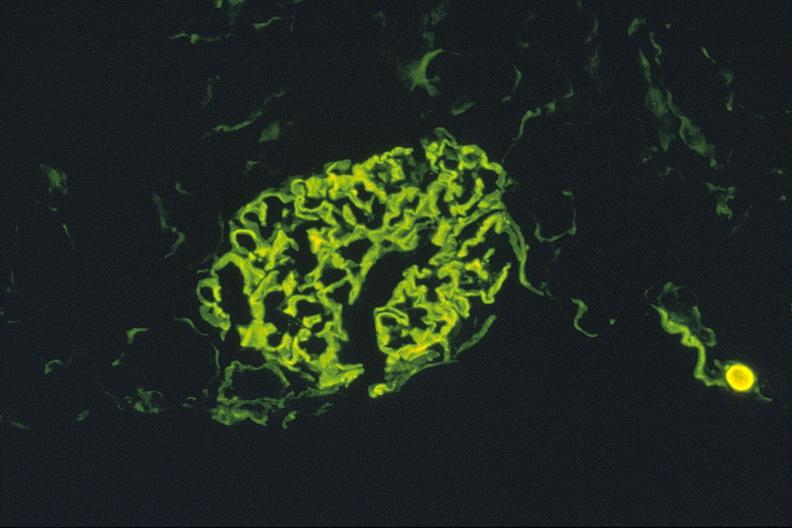does this image show antiglomerlar basement membrane, igg?
Answer the question using a single word or phrase. Yes 